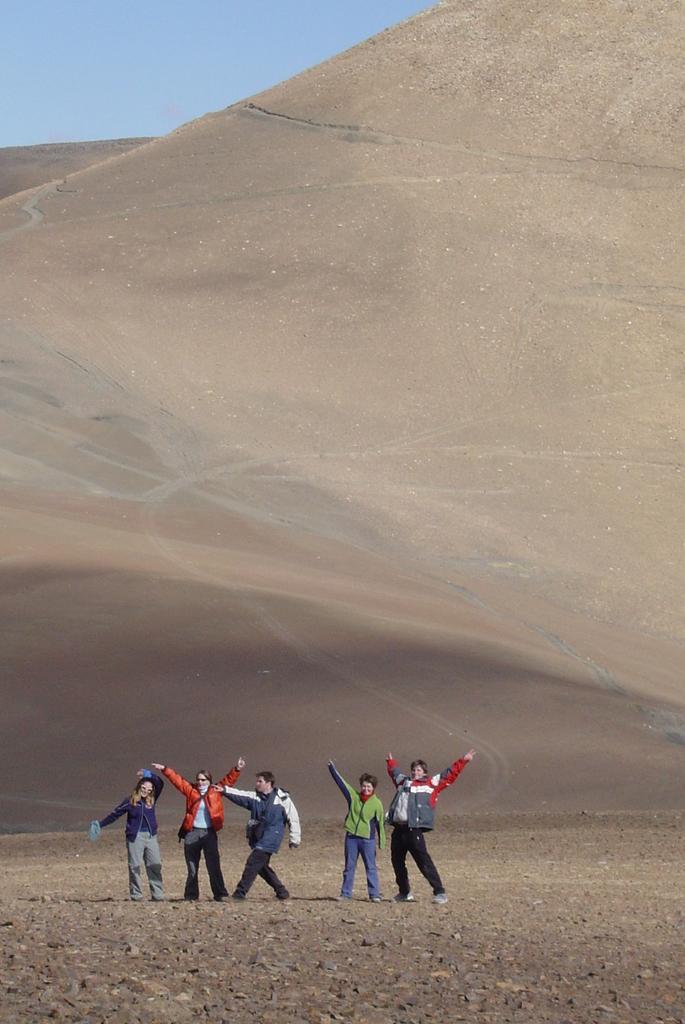Please provide a concise description of this image. In the image there are few persons in jerkins standing on the land and behind them there is a hill and above its sky. 